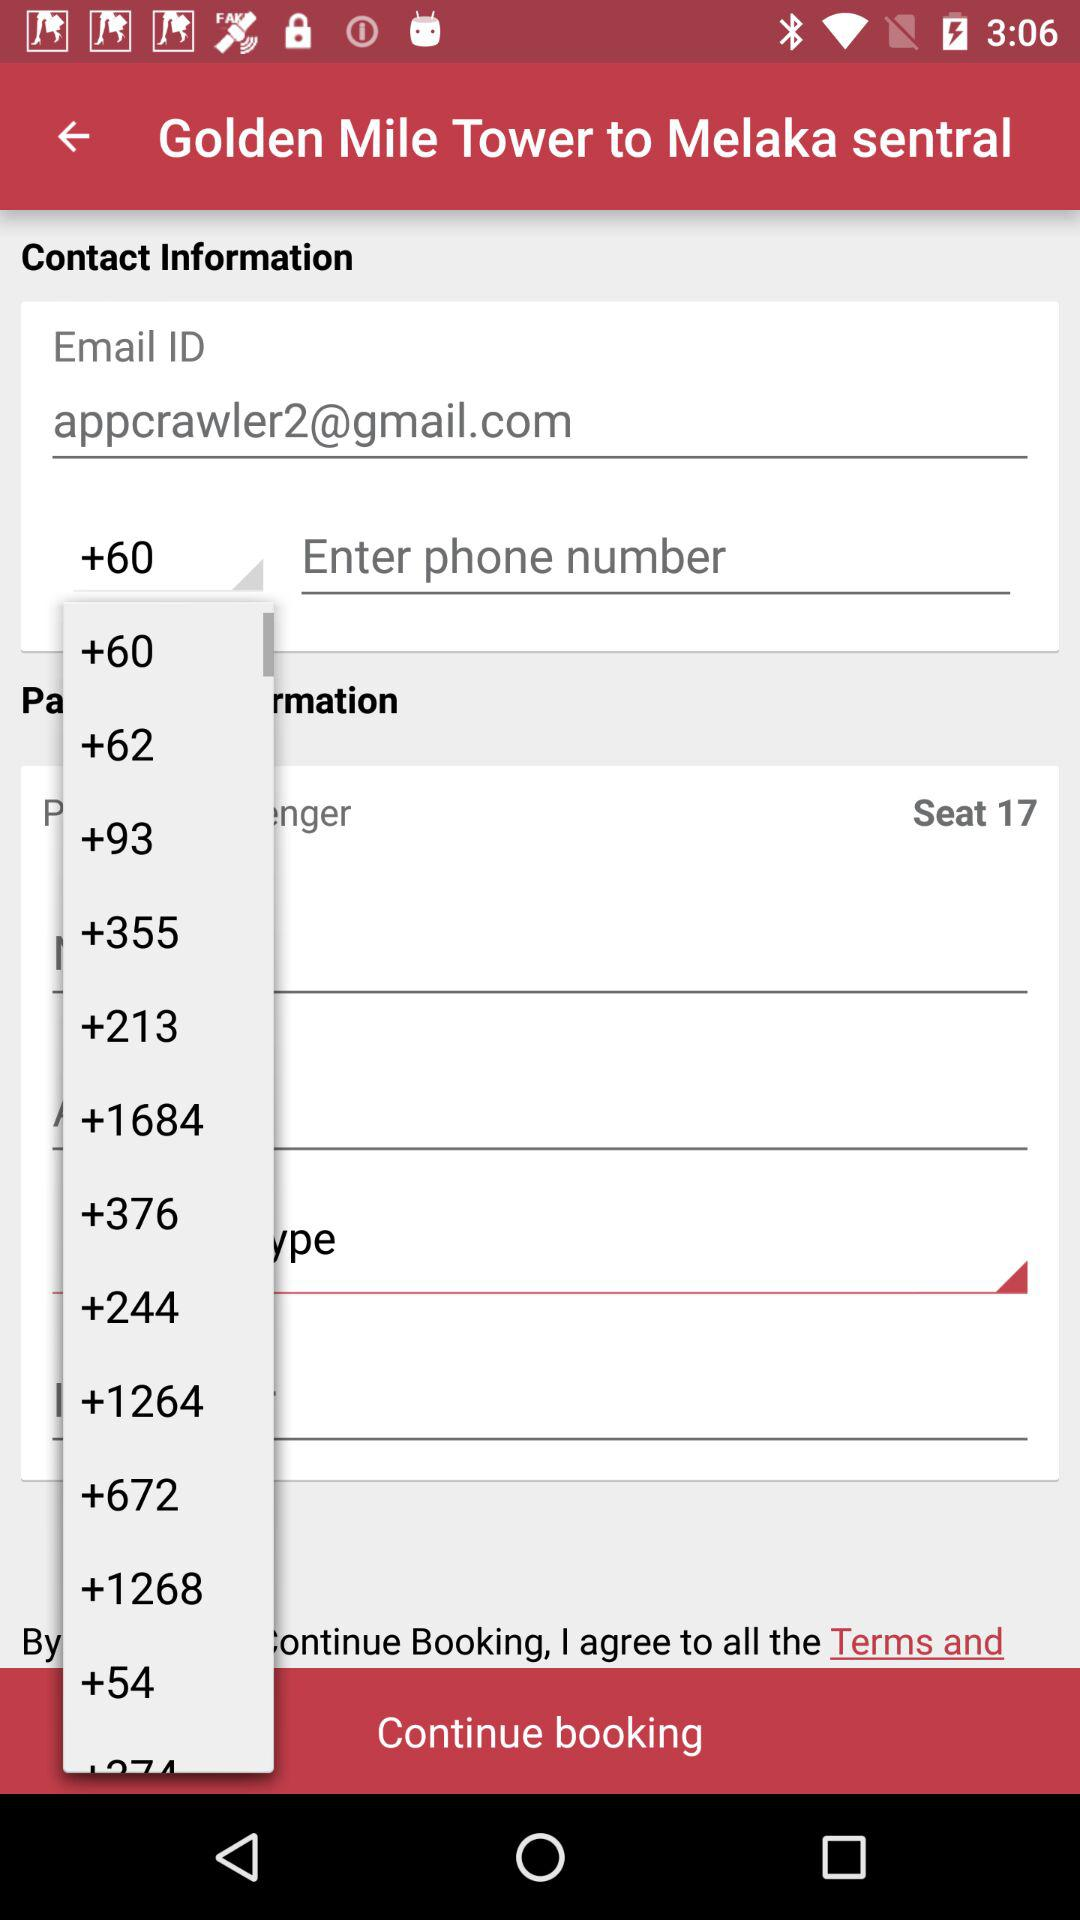Has the user agreed to the terms of service and privacy policy?
When the provided information is insufficient, respond with <no answer>. <no answer> 